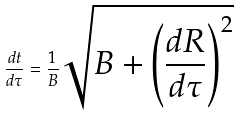Convert formula to latex. <formula><loc_0><loc_0><loc_500><loc_500>\frac { d t } { d \tau } = \frac { 1 } { B } \sqrt { B + \left ( \frac { d R } { d \tau } \right ) ^ { 2 } }</formula> 